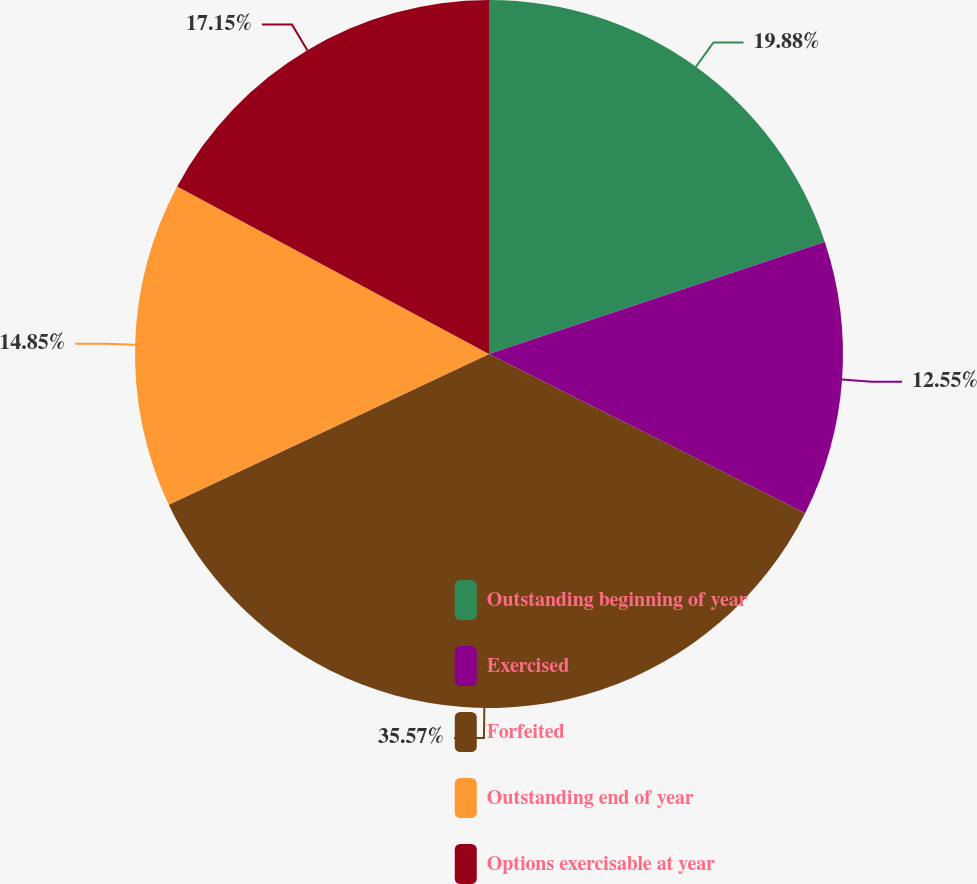<chart> <loc_0><loc_0><loc_500><loc_500><pie_chart><fcel>Outstanding beginning of year<fcel>Exercised<fcel>Forfeited<fcel>Outstanding end of year<fcel>Options exercisable at year<nl><fcel>19.87%<fcel>12.55%<fcel>35.56%<fcel>14.85%<fcel>17.15%<nl></chart> 